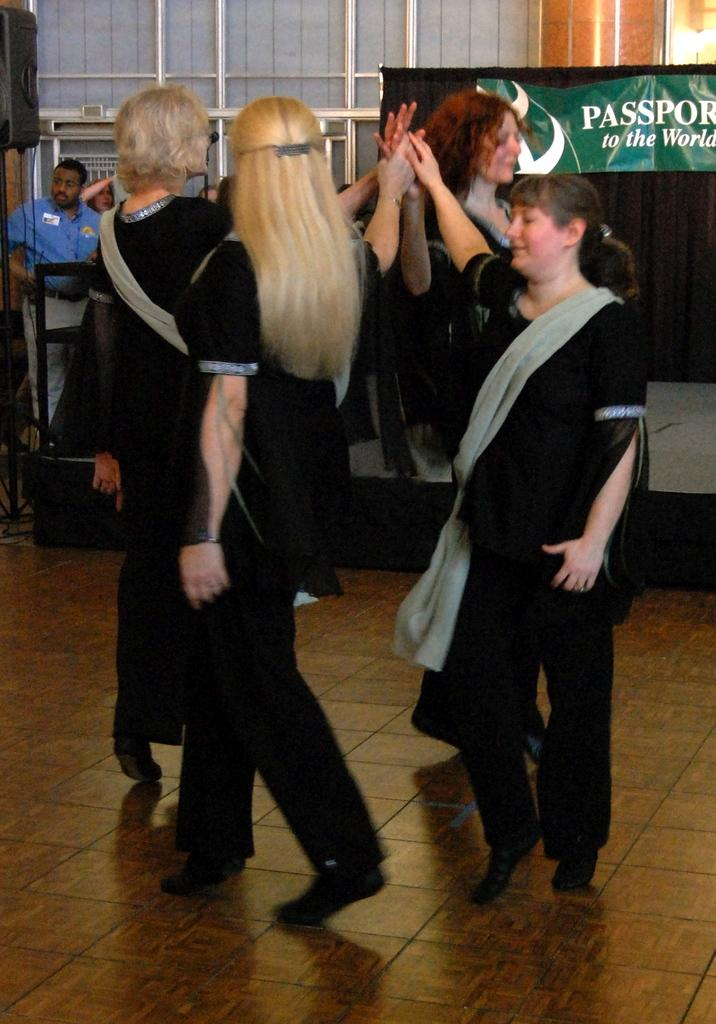How many groups of people can be seen in the image? There are people in the front and background of the image, so two groups of people can be seen. What is located in the background of the image? In the background of the image, there is a stage, curtains, a banner, a speaker, pillars, rods, and other unspecified things. What might be the purpose of the stage in the background? The stage in the background might be used for performances or presentations. What is the function of the rods in the background? The rods in the background might be used for hanging curtains or other decorations. What type of design can be seen on the laborer's clothing in the image? There is no laborer present in the image, so no design can be seen on their clothing. 